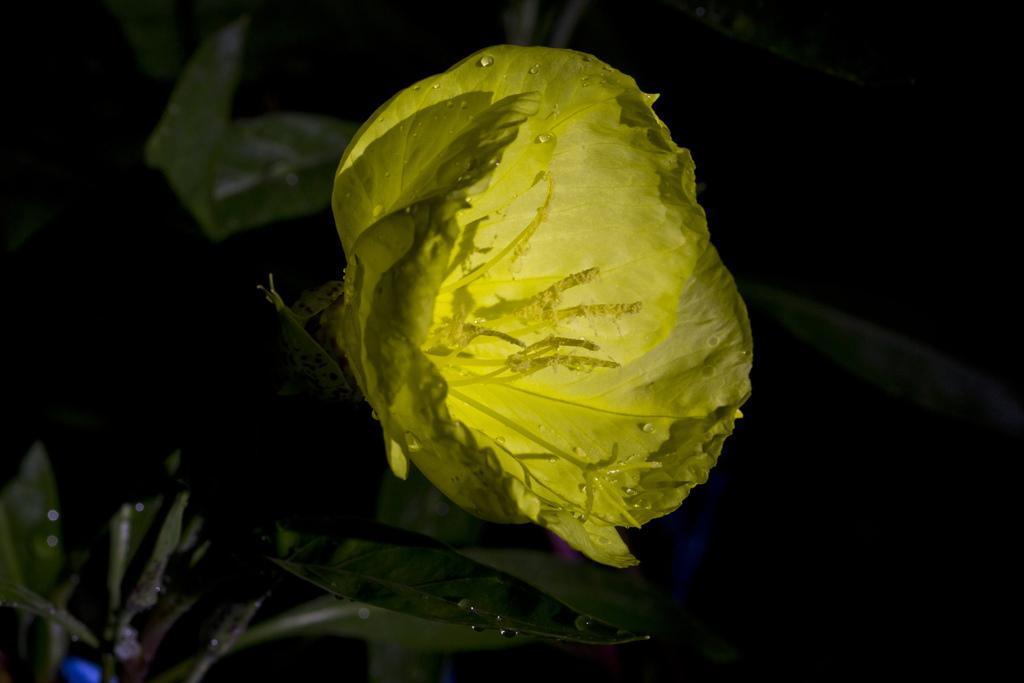How would you summarize this image in a sentence or two? In this picture I can see the yellow color flower on the plant. On the right I can see the darkness. At the bottom I can see some leaves. 